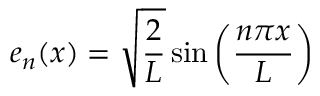Convert formula to latex. <formula><loc_0><loc_0><loc_500><loc_500>e _ { n } ( x ) = { \sqrt { \frac { 2 } { L } } } \sin \left ( { \frac { n \pi x } { L } } \right )</formula> 